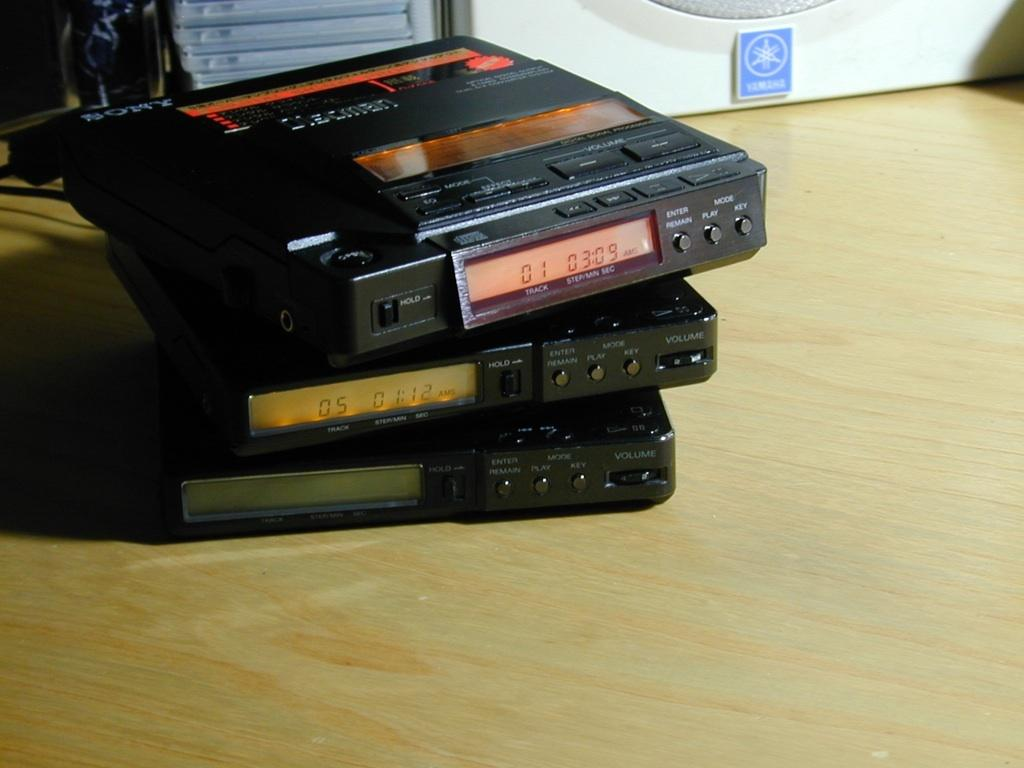What type of objects are present in the image? There are electronic devices in the image. What is the surface made of that the electronic devices are placed on? The electronic devices are on a wooden surface. What features do the electronic devices have? The devices have buttons and digital display boards. What can be seen on the devices? There is text on the devices. What is visible behind the electronic devices? There are boxes visible behind the electronic devices. What flavor of ice cream is being fought over by the screws in the image? There is no ice cream or screws present in the image, and therefore no such conflict can be observed. 